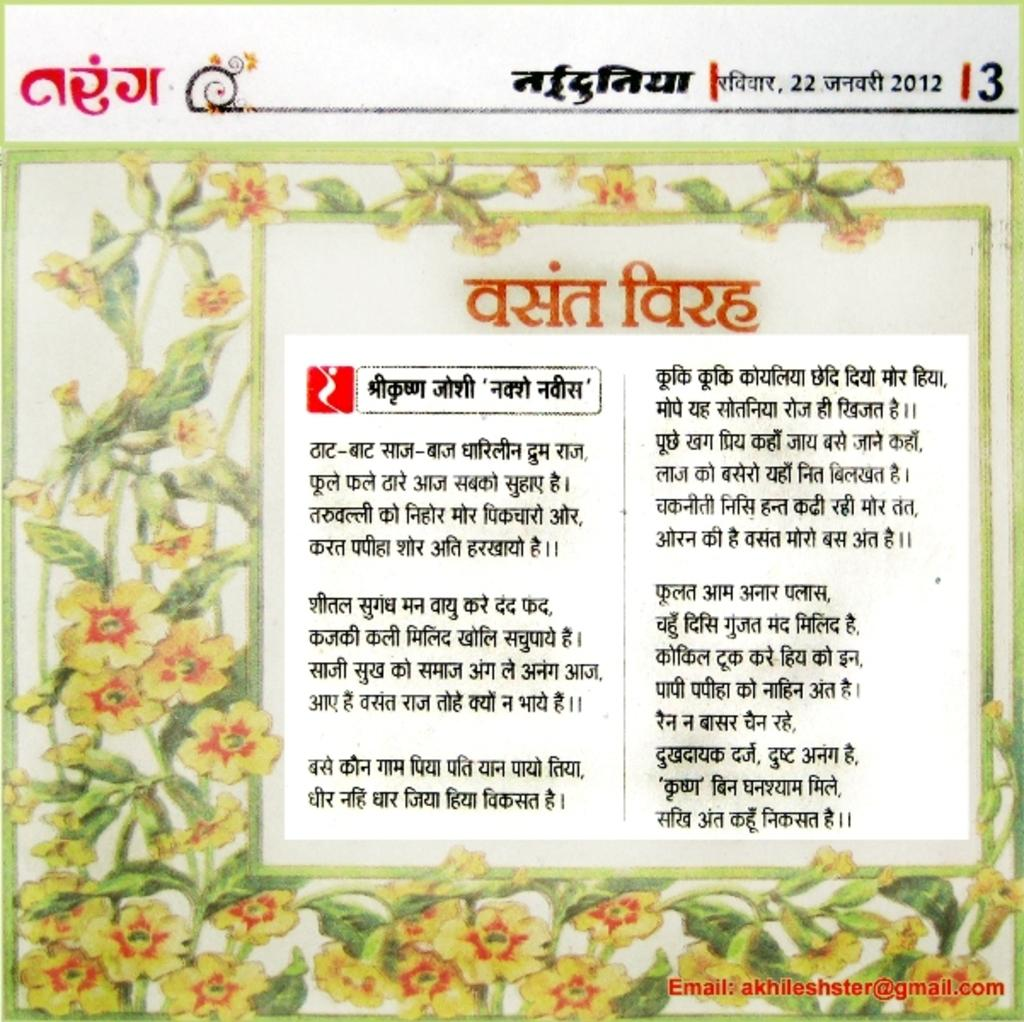What is the main subject of the poster in the image? The main subject of the poster in the image is flowers. Are there any other elements on the poster besides the flowers? Yes, there is a creeper with green leaves on the poster. Is there any text on the poster? Yes, there is text on the poster. How many fowl are depicted on the poster? There are no fowl depicted on the poster; it features images of flowers and a creeper with green leaves. What type of needle is used to sew the text on the poster? There is no needle present in the image, and the text appears to be printed rather than sewn. 